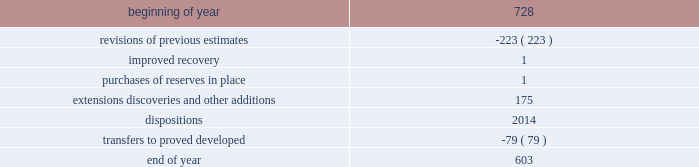During 2015 , 2014 and 2013 , netherland , sewell & associates , inc .
( "nsai" ) prepared a certification of the prior year's reserves for the alba field in e.g .
The nsai summary reports are filed as an exhibit to this annual report on form 10-k .
Members of the nsai team have multiple years of industry experience , having worked for large , international oil and gas companies before joining nsai .
The senior technical advisor has over 35 years of practical experience in petroleum geosciences , with over 15 years experience in the estimation and evaluation of reserves .
The second team member has over 10 years of practical experience in petroleum engineering , with over five years experience in the estimation and evaluation of reserves .
Both are registered professional engineers in the state of texas .
Ryder scott company ( "ryder scott" ) also performed audits of the prior years' reserves of several of our fields in 2015 , 2014 and 2013 .
Their summary reports are filed as exhibits to this annual report on form 10-k .
The team lead for ryder scott has over 20 years of industry experience , having worked for a major international oil and gas company before joining ryder scott .
He is a member of spe , where he served on the oil and gas reserves committee , and is a registered professional engineer in the state of texas .
Changes in proved undeveloped reserves as of december 31 , 2015 , 603 mmboe of proved undeveloped reserves were reported , a decrease of 125 mmboe from december 31 , 2014 .
The table shows changes in total proved undeveloped reserves for 2015 : ( mmboe ) .
The revisions to previous estimates were largely due to a result of reductions to our capital development program which deferred proved undeveloped reserves beyond the 5-year plan .
A total of 139 mmboe was booked as extensions , discoveries or other additions and revisions due to the application of reliable technology .
Technologies included statistical analysis of production performance , decline curve analysis , pressure and rate transient analysis , reservoir simulation and volumetric analysis .
The observed statistical nature of production performance coupled with highly certain reservoir continuity or quality within the reliable technology areas and sufficient proved developed locations establish the reasonable certainty criteria required for booking proved reserves .
Transfers from proved undeveloped to proved developed reserves included 47 mmboe in the eagle ford , 14 mmboe in the bakken and 5 mmboe in the oklahoma resource basins due to development drilling and completions .
Costs incurred in 2015 , 2014 and 2013 relating to the development of proved undeveloped reserves were $ 1415 million , $ 3149 million and $ 2536 million .
Projects can remain in proved undeveloped reserves for extended periods in certain situations such as large development projects which take more than five years to complete , or the timing of when additional gas compression is needed .
Of the 603 mmboe of proved undeveloped reserves at december 31 , 2015 , 26% ( 26 % ) of the volume is associated with projects that have been included in proved reserves for more than five years .
The majority of this volume is related to a compression project in e.g .
That was sanctioned by our board of directors in 2004 .
During 2012 , the compression project received the approval of the e.g .
Government , fabrication of the new platform began in 2013 and installation of the platform at the alba field occurred in january 2016 .
Commissioning is currently underway , with first production expected by mid-2016 .
Proved undeveloped reserves for the north gialo development , located in the libyan sahara desert , were booked for the first time in 2010 .
This development is being executed by the operator and encompasses a multi-year drilling program including the design , fabrication and installation of extensive liquid handling and gas recycling facilities .
Anecdotal evidence from similar development projects in the region leads to an expected project execution time frame of more than five years from the time the reserves were initially booked .
Interruptions associated with the civil and political unrest have also extended the project duration .
Operations were interrupted in mid-2013 as a result of the shutdown of the es sider crude oil terminal , and although temporarily re-opened during the second half of 2014 , production remains shut-in through early 2016 .
The operator is committed to the project 2019s completion and continues to assign resources in order to execute the project .
Our conversion rate for proved undeveloped reserves to proved developed reserves for 2015 was 11% ( 11 % ) .
However , excluding the aforementioned long-term projects in e.g .
And libya , our 2015 conversion rate would be 15% ( 15 % ) .
Furthermore , our .
What were total costs incurred in 2015 , 2014 and 2013 relating to the development of proved undeveloped reserves , in million? 
Computations: ((1415 + 3149) + 2536)
Answer: 7100.0. 